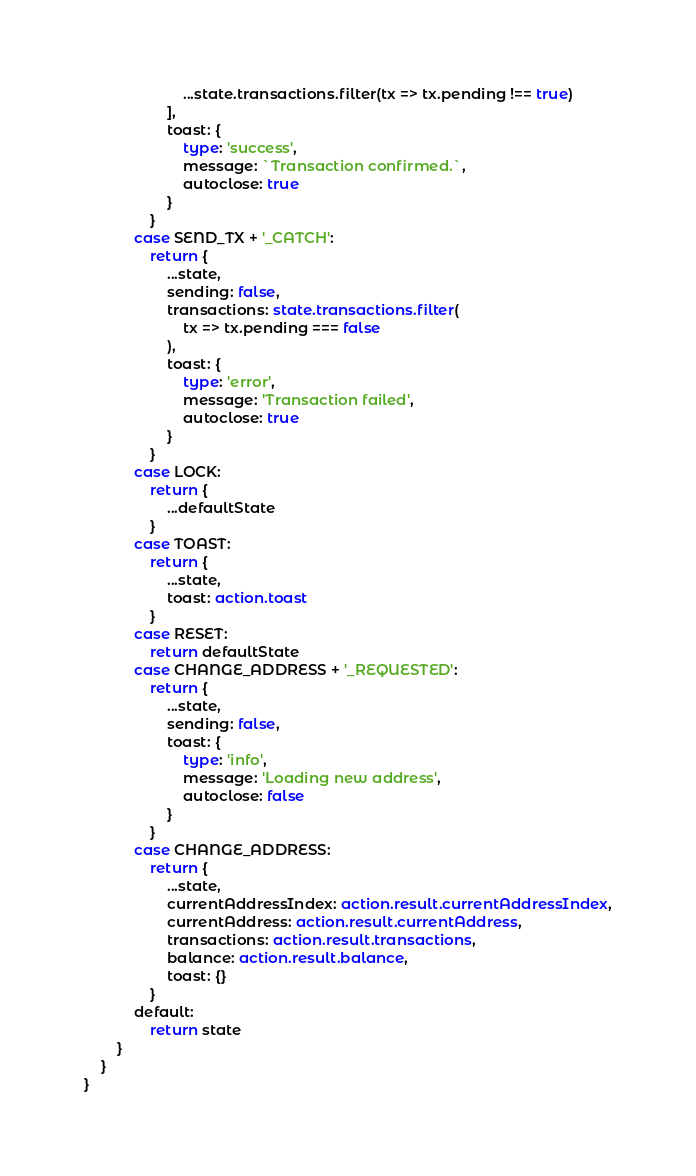<code> <loc_0><loc_0><loc_500><loc_500><_TypeScript_>						...state.transactions.filter(tx => tx.pending !== true)
					],
					toast: {
						type: 'success',
						message: `Transaction confirmed.`,
						autoclose: true
					}
				}
			case SEND_TX + '_CATCH':
				return {
					...state,
					sending: false,
					transactions: state.transactions.filter(
						tx => tx.pending === false
					),
					toast: {
						type: 'error',
						message: 'Transaction failed',
						autoclose: true
					}
				}
			case LOCK:
				return {
					...defaultState
				}
			case TOAST:
				return {
					...state,
					toast: action.toast
				}
			case RESET:
				return defaultState
			case CHANGE_ADDRESS + '_REQUESTED':
				return {
					...state,
					sending: false,
					toast: {
						type: 'info',
						message: 'Loading new address',
						autoclose: false
					}
				}
			case CHANGE_ADDRESS:
				return {
					...state,
					currentAddressIndex: action.result.currentAddressIndex,
					currentAddress: action.result.currentAddress,
					transactions: action.result.transactions,
					balance: action.result.balance,
					toast: {}
				}
			default:
				return state
		}
	}
}
</code> 